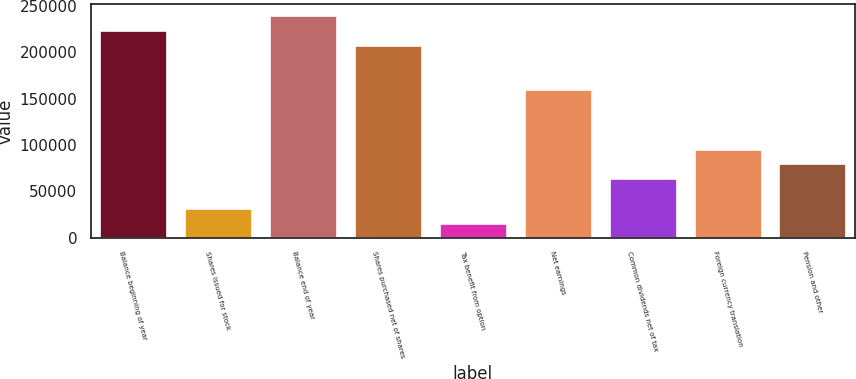Convert chart. <chart><loc_0><loc_0><loc_500><loc_500><bar_chart><fcel>Balance beginning of year<fcel>Shares issued for stock<fcel>Balance end of year<fcel>Shares purchased net of shares<fcel>Tax benefit from option<fcel>Net earnings<fcel>Common dividends net of tax<fcel>Foreign currency translation<fcel>Pension and other<nl><fcel>224035<fcel>32010.2<fcel>240038<fcel>208033<fcel>16008.1<fcel>160027<fcel>64014.4<fcel>96018.6<fcel>80016.5<nl></chart> 